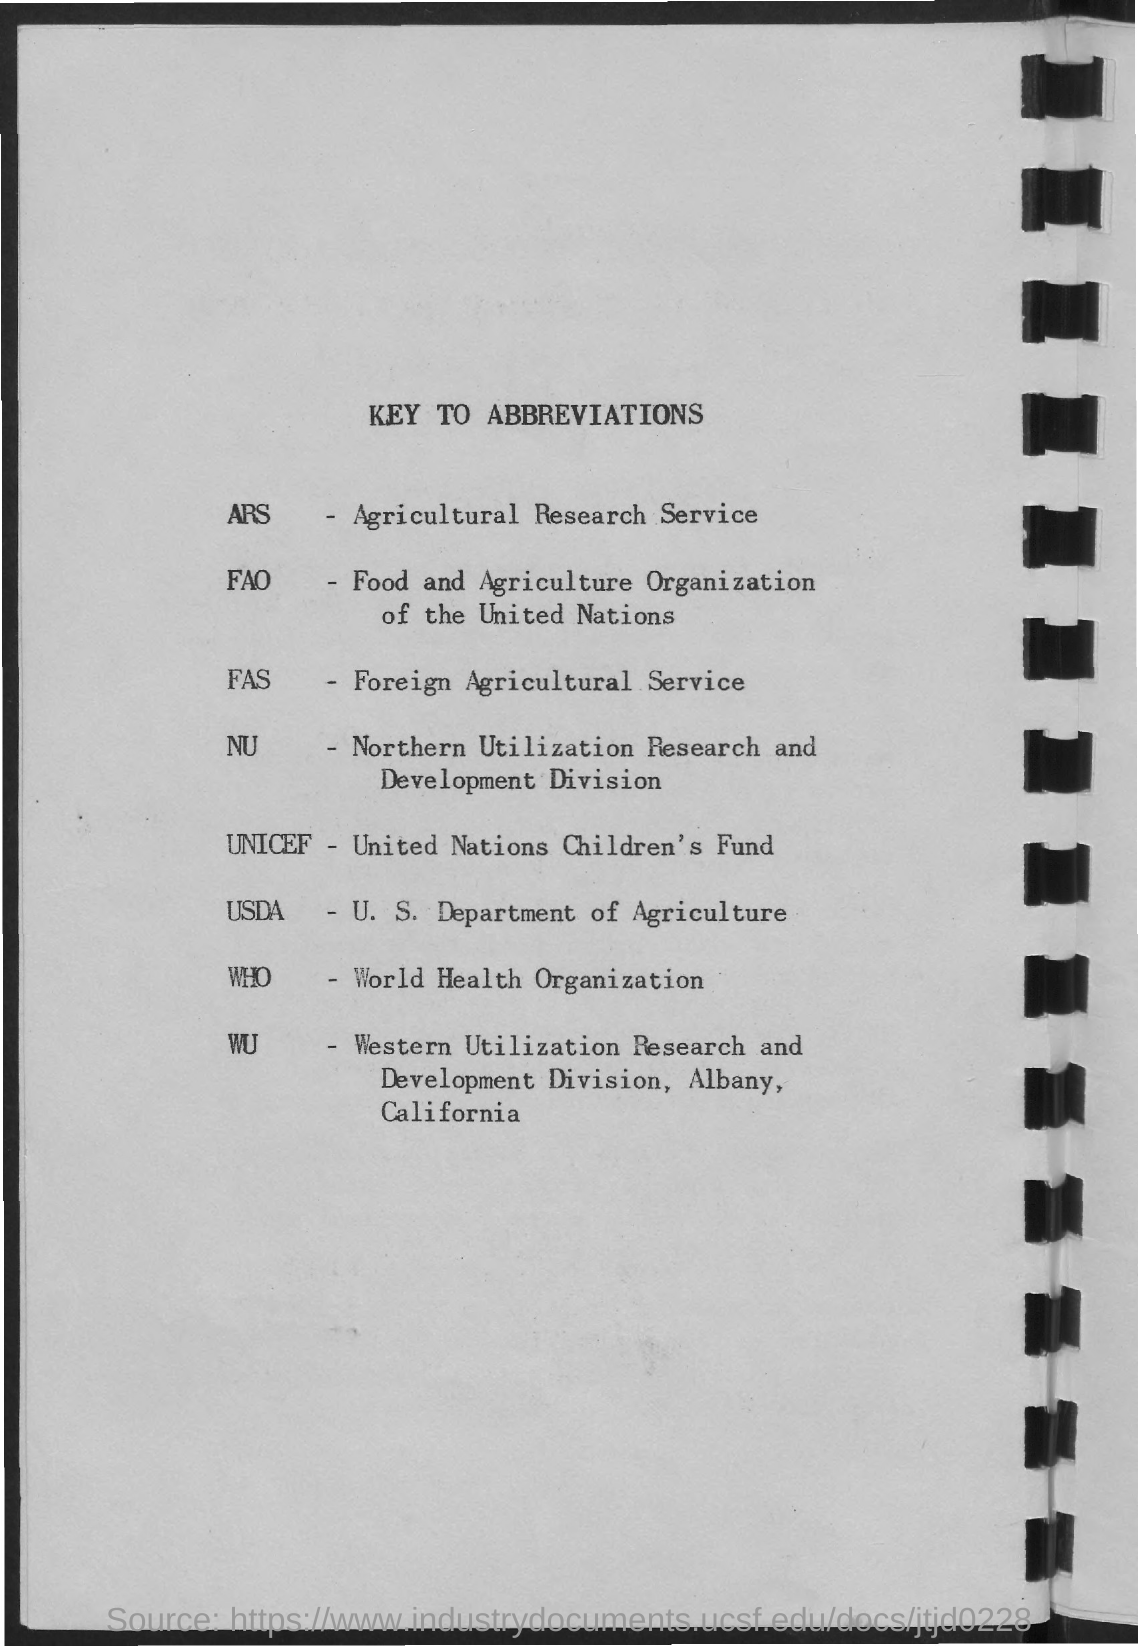Outline some significant characteristics in this image. The World Health Organization (WHO) is an international organization that focuses on improving health and healthcare worldwide. Foreign Agricultural Service (FAS) is a U.S. government agency that promotes U.S. agricultural exports and provides market information to foreign buyers. UNICEF, which stands for the United Nations Children's Fund, is an organization that works to promote and protect the rights of children around the world. 